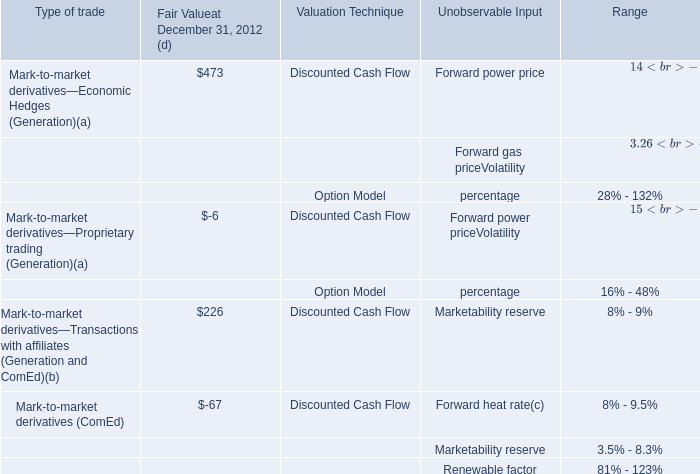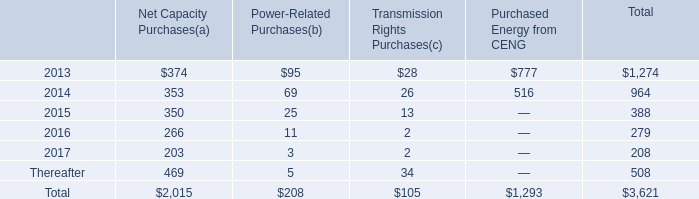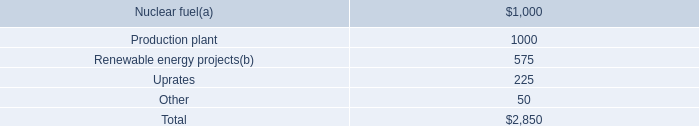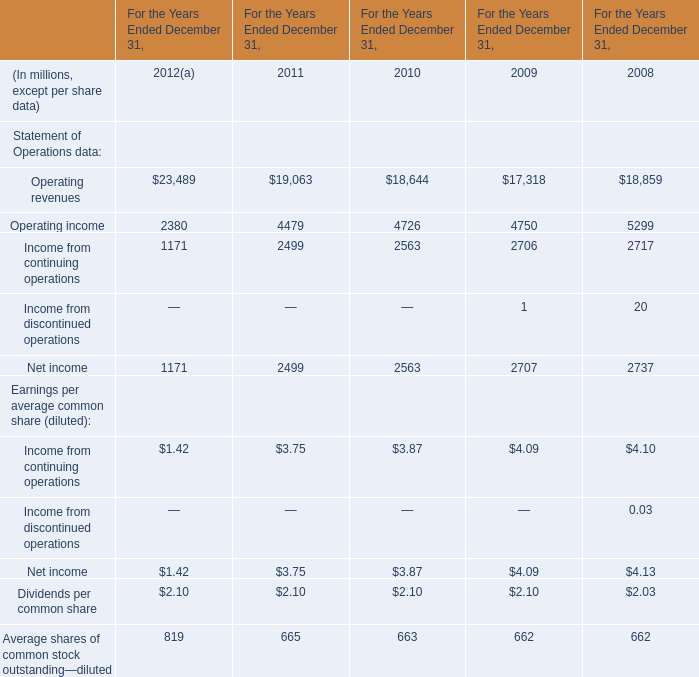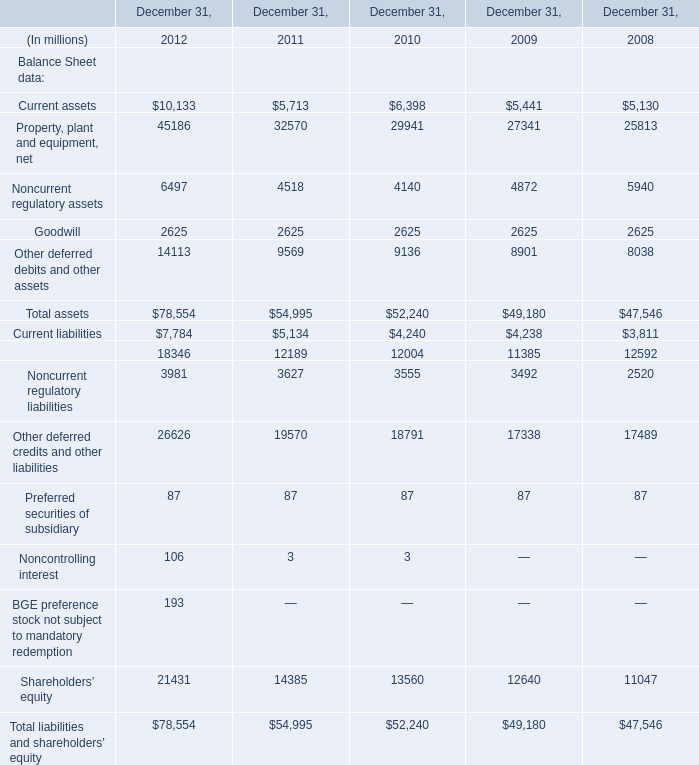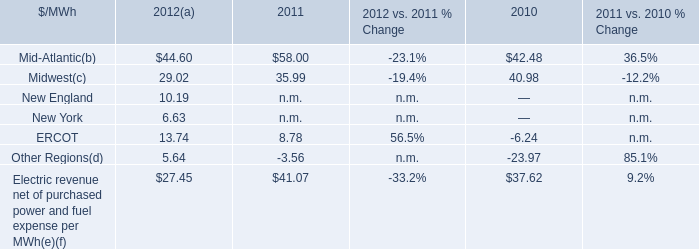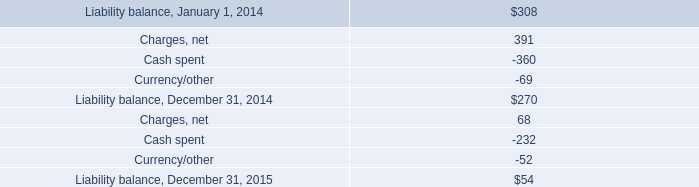If Total assets develops with the same increasing rate in 2012, what will it reach in 2013? (in dollars in millions) 
Computations: (78554 * (1 + ((78554 - 54995) / 54995)))
Answer: 112205.30805. 